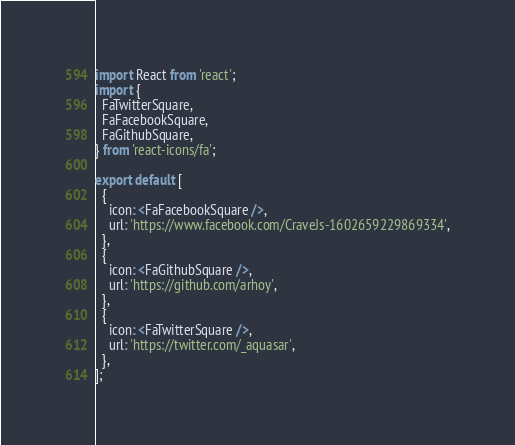Convert code to text. <code><loc_0><loc_0><loc_500><loc_500><_JavaScript_>import React from 'react';
import {
  FaTwitterSquare,
  FaFacebookSquare,
  FaGithubSquare,
} from 'react-icons/fa';

export default [
  {
    icon: <FaFacebookSquare />,
    url: 'https://www.facebook.com/CraveJs-1602659229869334',
  },
  {
    icon: <FaGithubSquare />,
    url: 'https://github.com/arhoy',
  },
  {
    icon: <FaTwitterSquare />,
    url: 'https://twitter.com/_aquasar',
  },
];
</code> 